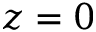Convert formula to latex. <formula><loc_0><loc_0><loc_500><loc_500>z = 0</formula> 